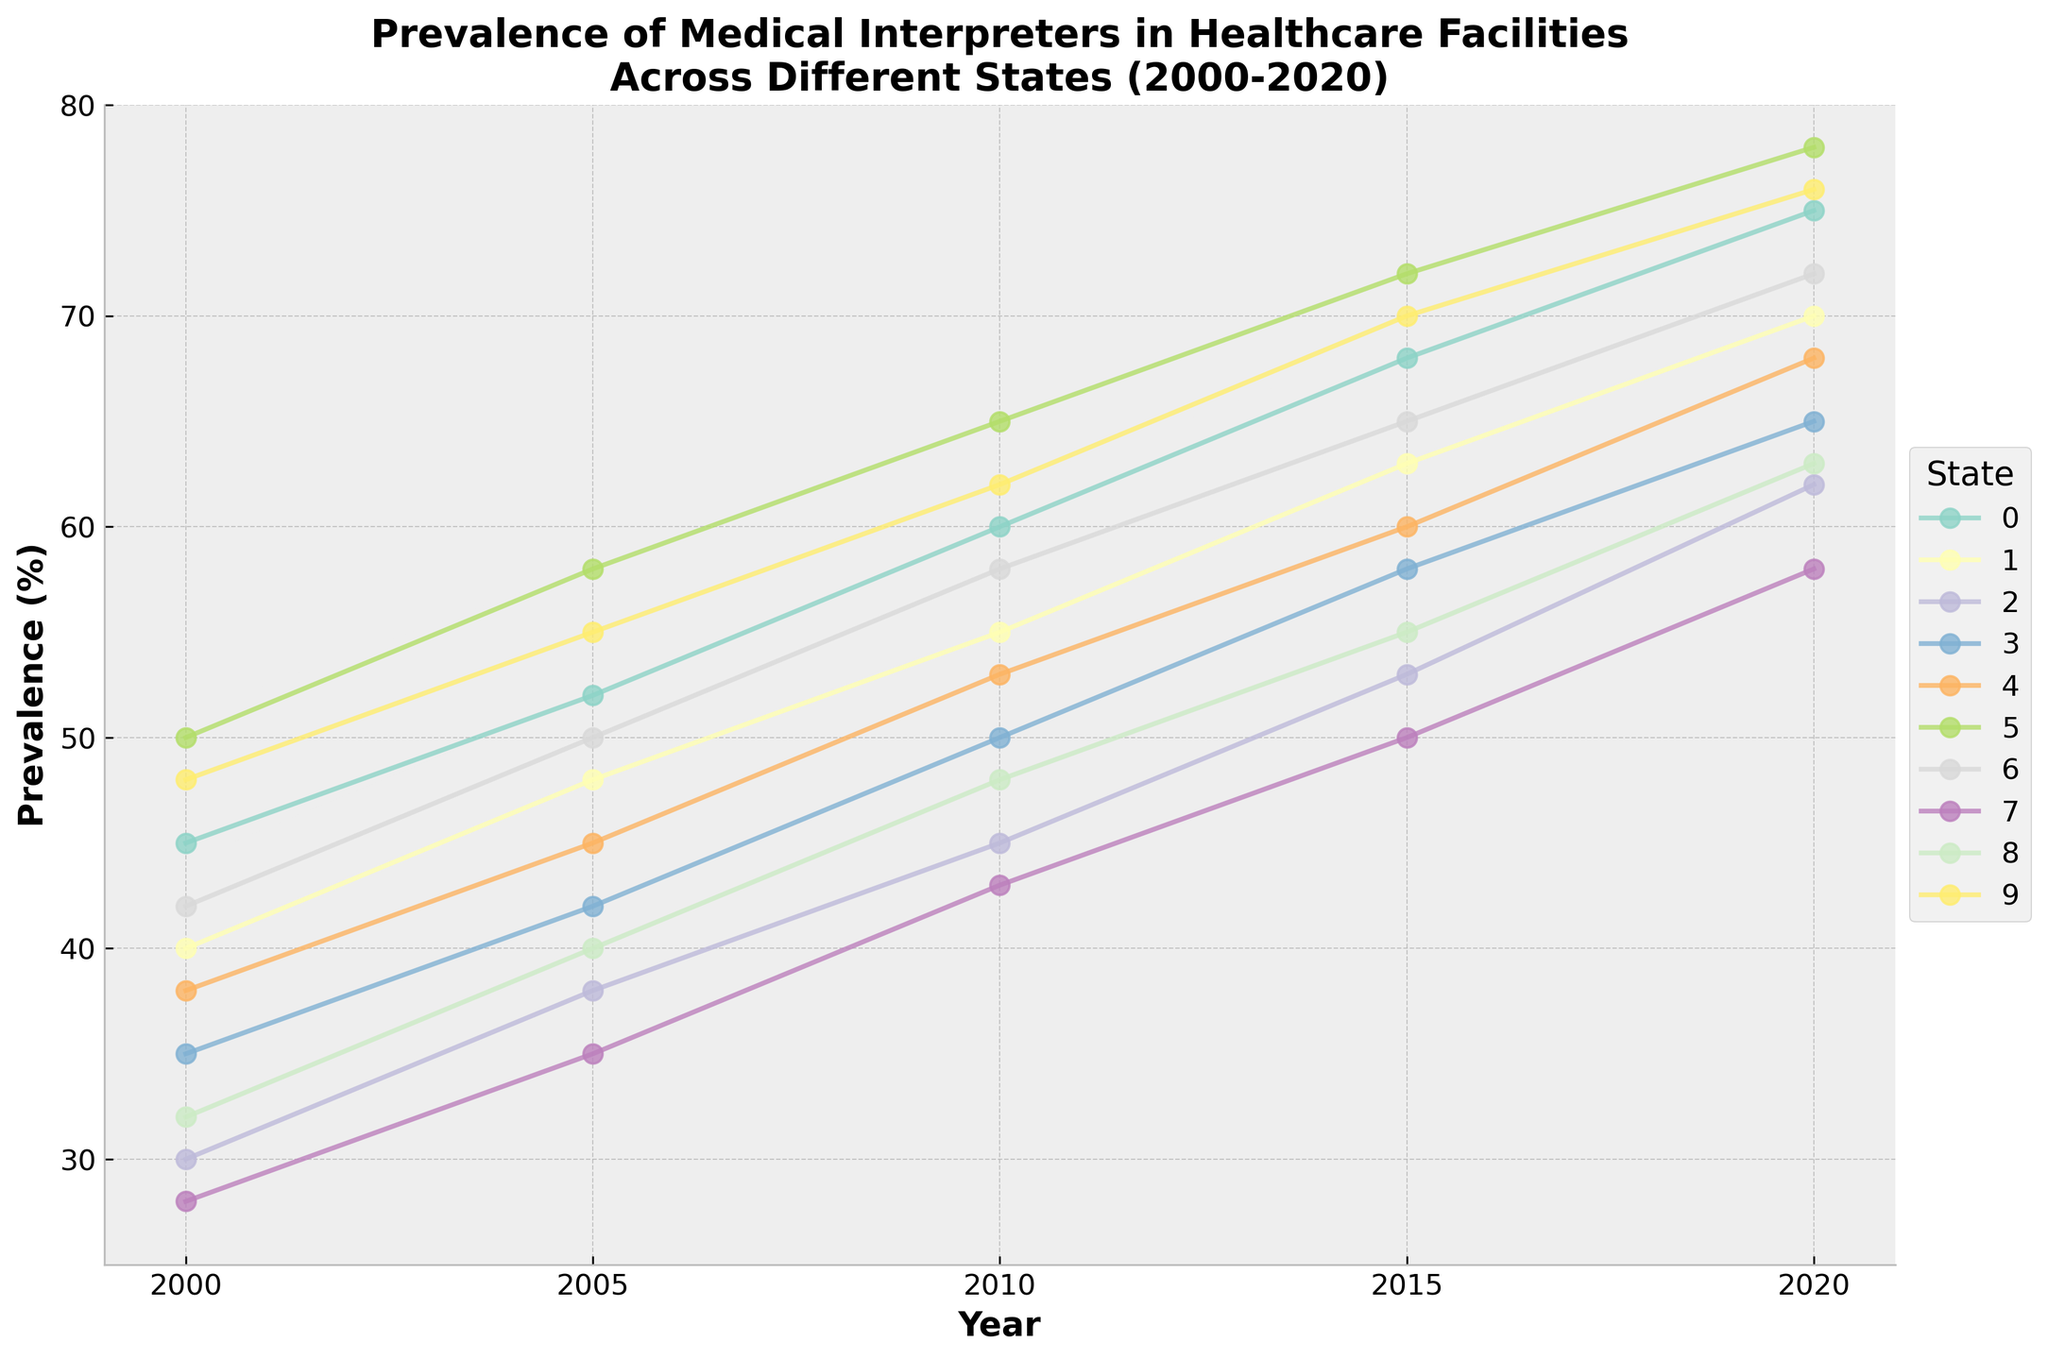What is the trend of prevalence of medical interpreters in California from 2000 to 2020? To determine the trend, observe the line corresponding to California and note the change in prevalence over the years 2000, 2005, 2010, 2015, and 2020. It shows a steady increase from 45% to 75% over the two decades.
Answer: Steady increase Which state had the highest prevalence of medical interpreters in 2020? To find this, look for the highest point in the year 2020 on the x-axis. Massachusetts has the highest prevalence in 2020, reaching 78%.
Answer: Massachusetts Which states show a prevalence of over 70% in 2020? Observe the y-axis at the 2020 mark and identify the states that have points above 70%. These states are California, Massachusetts, Hawaii, and Washington.
Answer: California, Massachusetts, Hawaii, Washington Compare the growth in prevalence of medical interpreters in Texas and Florida from 2000 to 2020. Which state had a higher increase? Calculate the difference in prevalence for each state between 2000 and 2020. For Texas, it’s 62% - 30% = 32%; for Florida, it’s 65% - 35% = 30%. Texas had a higher increase.
Answer: Texas What is the average prevalence of medical interpreters in New York over the five data points presented (2000, 2005, 2010, 2015, 2020)? Sum the prevalence values for New York across the five years and divide by the number of years: (40 + 48 + 55 + 63 + 70)/5 = 55.2%.
Answer: 55.2% Between 2000 and 2020, which state showed the least change in the prevalence of medical interpreters? Calculate the difference between 2000 and 2020 for each state and compare. Massachusetts had the least change with an increase of 28% (78% - 50%) compared to other states.
Answer: Massachusetts Which state had the lowest prevalence of medical interpreters in 2010, and what was the value? Identify the lowest point on the line corresponding to the year 2010 across all states. Arizona had the lowest prevalence with 43%.
Answer: Arizona, 43% How did the prevalence of medical interpreters in Illinois change from 2000 to 2015? Check the points for Illinois in 2000 and 2015 and compute the difference. The prevalence increased from 38% to 60%, a change of 22%.
Answer: Increase by 22% What is the median prevalence of medical interpreters in 2010 across all states? List the 2010 prevalence values from all states, sort them, and find the median: [43, 45, 48, 50, 53, 55, 58, 60, 62, 65]. The median value for 2010 is (53+55)/2 = 54%.
Answer: 54% How many states had a prevalence between 50% and 60% inclusive in 2015? Scan the points from 2015 and count those falling between 50% and 60%. The states are Texas (53%), New Mexico (55%), Illinois (60%), and Washington (58%). There are 4 states in this range.
Answer: 4 